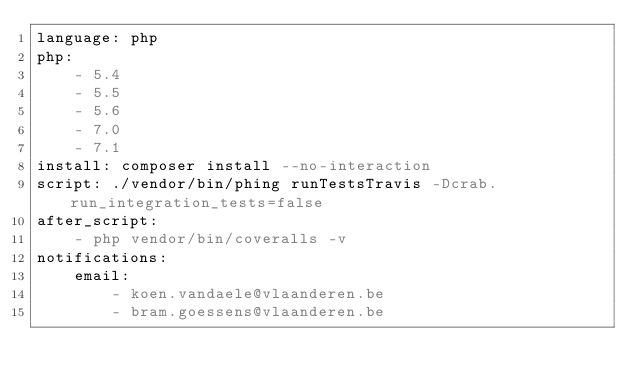<code> <loc_0><loc_0><loc_500><loc_500><_YAML_>language: php
php:
    - 5.4
    - 5.5
    - 5.6
    - 7.0
    - 7.1
install: composer install --no-interaction
script: ./vendor/bin/phing runTestsTravis -Dcrab.run_integration_tests=false
after_script:
    - php vendor/bin/coveralls -v
notifications:
    email:
        - koen.vandaele@vlaanderen.be
        - bram.goessens@vlaanderen.be
</code> 